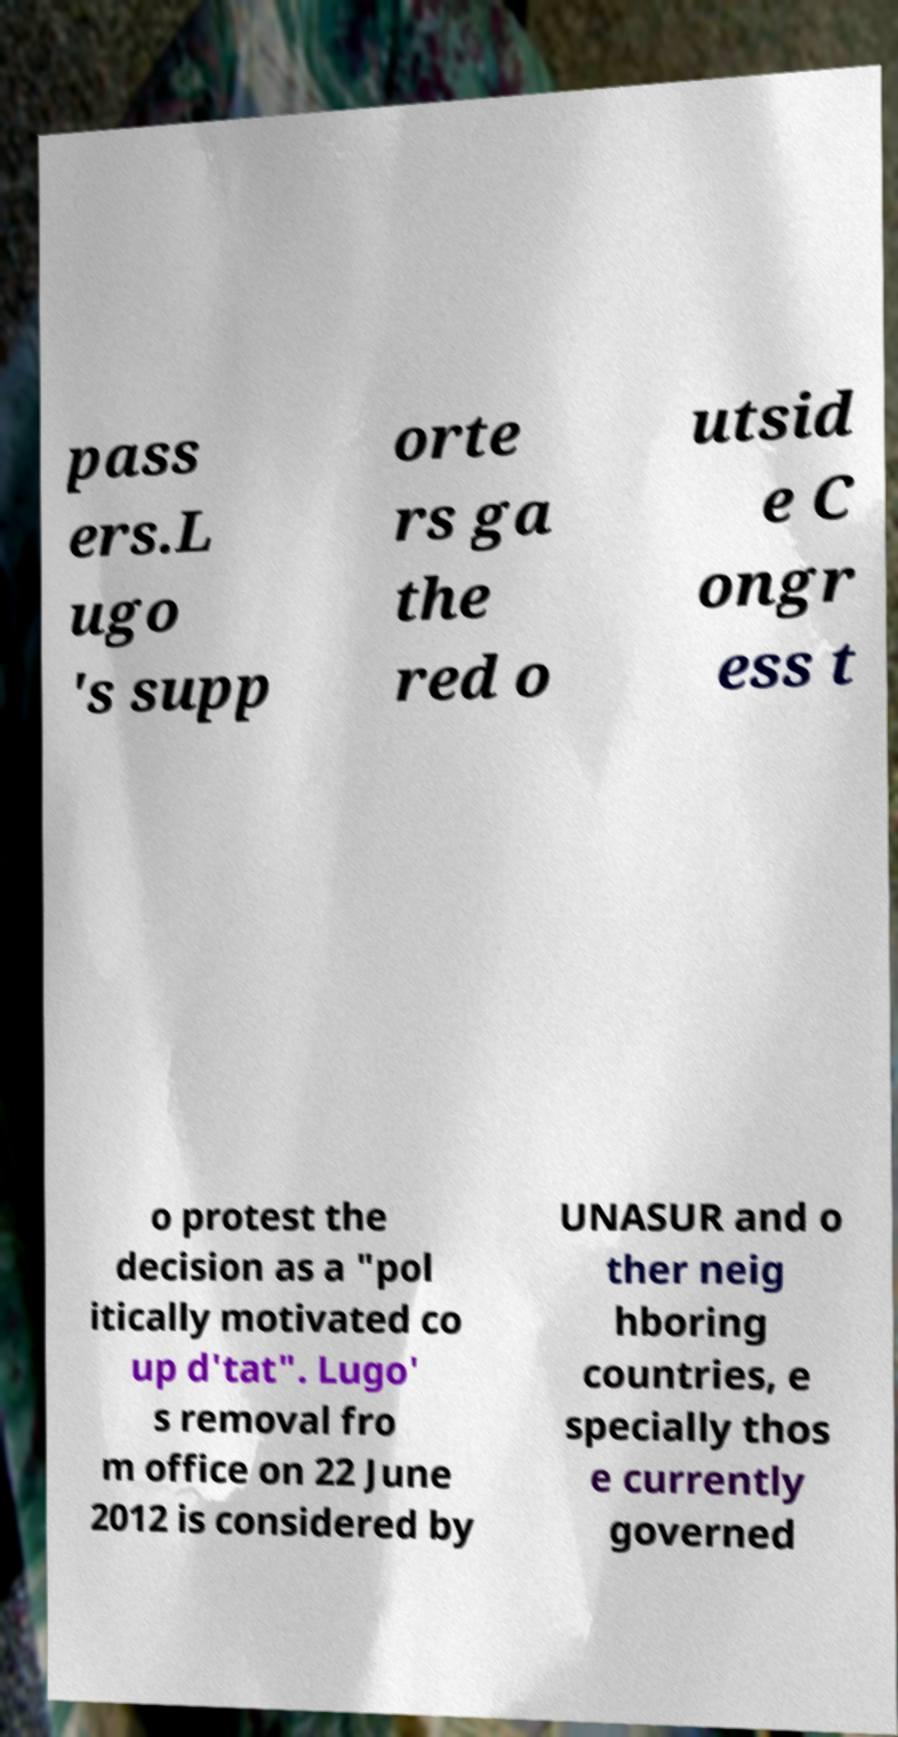Can you read and provide the text displayed in the image?This photo seems to have some interesting text. Can you extract and type it out for me? pass ers.L ugo 's supp orte rs ga the red o utsid e C ongr ess t o protest the decision as a "pol itically motivated co up d'tat". Lugo' s removal fro m office on 22 June 2012 is considered by UNASUR and o ther neig hboring countries, e specially thos e currently governed 